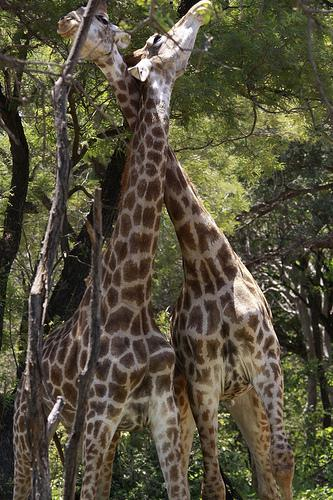Question: how many legs are shown?
Choices:
A. 8.
B. 4.
C. 2.
D. 1.
Answer with the letter. Answer: A Question: what is the giraffe eating?
Choices:
A. Bushes.
B. Leaves.
C. Flowers.
D. Ham.
Answer with the letter. Answer: B Question: how many giraffes?
Choices:
A. 2.
B. 1.
C. 3.
D. 4.
Answer with the letter. Answer: A Question: what color are the giraffes?
Choices:
A. Brown, tan and white.
B. Brown and white.
C. Dark brown, tan and white.
D. Tan and white.
Answer with the letter. Answer: B Question: why is the sky not visible?
Choices:
A. The clouds.
B. The trees.
C. The bushes.
D. The flowers.
Answer with the letter. Answer: B 